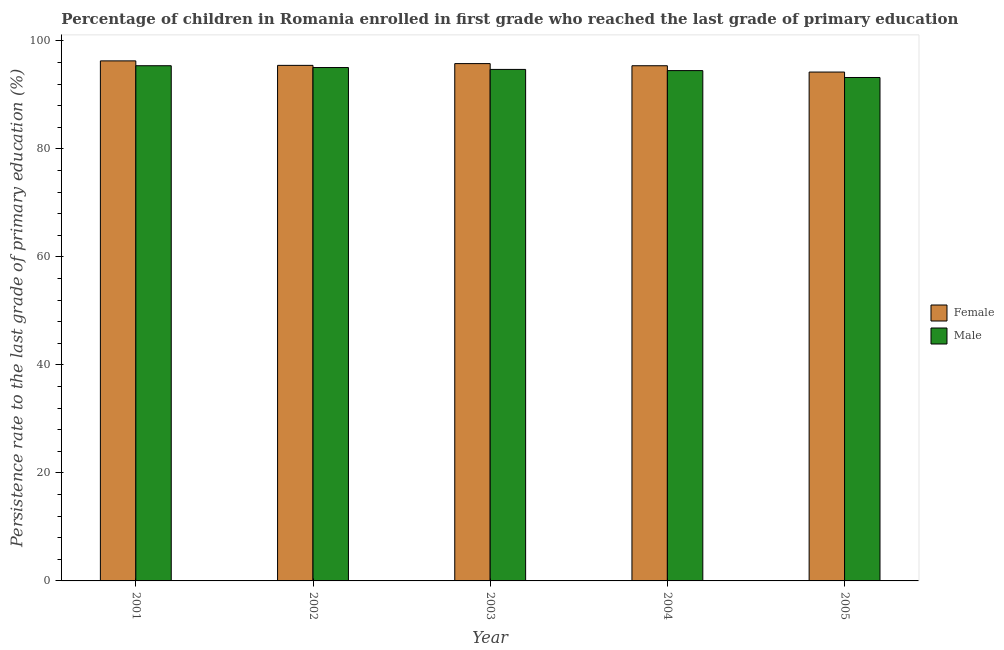How many groups of bars are there?
Provide a succinct answer. 5. Are the number of bars on each tick of the X-axis equal?
Ensure brevity in your answer.  Yes. How many bars are there on the 1st tick from the left?
Your response must be concise. 2. What is the persistence rate of female students in 2004?
Make the answer very short. 95.39. Across all years, what is the maximum persistence rate of male students?
Make the answer very short. 95.39. Across all years, what is the minimum persistence rate of male students?
Your response must be concise. 93.21. In which year was the persistence rate of female students maximum?
Ensure brevity in your answer.  2001. What is the total persistence rate of female students in the graph?
Your answer should be compact. 477.14. What is the difference between the persistence rate of female students in 2003 and that in 2005?
Offer a very short reply. 1.57. What is the difference between the persistence rate of male students in 2004 and the persistence rate of female students in 2002?
Provide a succinct answer. -0.57. What is the average persistence rate of female students per year?
Provide a short and direct response. 95.43. In the year 2003, what is the difference between the persistence rate of female students and persistence rate of male students?
Your answer should be very brief. 0. In how many years, is the persistence rate of male students greater than 68 %?
Make the answer very short. 5. What is the ratio of the persistence rate of female students in 2001 to that in 2003?
Ensure brevity in your answer.  1.01. Is the persistence rate of female students in 2002 less than that in 2004?
Keep it short and to the point. No. Is the difference between the persistence rate of male students in 2002 and 2004 greater than the difference between the persistence rate of female students in 2002 and 2004?
Offer a terse response. No. What is the difference between the highest and the second highest persistence rate of female students?
Make the answer very short. 0.5. What is the difference between the highest and the lowest persistence rate of female students?
Offer a terse response. 2.07. Is the sum of the persistence rate of female students in 2001 and 2003 greater than the maximum persistence rate of male students across all years?
Your answer should be compact. Yes. What does the 2nd bar from the right in 2002 represents?
Give a very brief answer. Female. How many bars are there?
Your answer should be very brief. 10. How many years are there in the graph?
Keep it short and to the point. 5. What is the difference between two consecutive major ticks on the Y-axis?
Your answer should be compact. 20. Where does the legend appear in the graph?
Provide a succinct answer. Center right. What is the title of the graph?
Provide a succinct answer. Percentage of children in Romania enrolled in first grade who reached the last grade of primary education. What is the label or title of the Y-axis?
Make the answer very short. Persistence rate to the last grade of primary education (%). What is the Persistence rate to the last grade of primary education (%) of Female in 2001?
Your answer should be compact. 96.29. What is the Persistence rate to the last grade of primary education (%) in Male in 2001?
Offer a very short reply. 95.39. What is the Persistence rate to the last grade of primary education (%) of Female in 2002?
Give a very brief answer. 95.46. What is the Persistence rate to the last grade of primary education (%) of Male in 2002?
Offer a very short reply. 95.05. What is the Persistence rate to the last grade of primary education (%) of Female in 2003?
Give a very brief answer. 95.78. What is the Persistence rate to the last grade of primary education (%) of Male in 2003?
Ensure brevity in your answer.  94.71. What is the Persistence rate to the last grade of primary education (%) in Female in 2004?
Keep it short and to the point. 95.39. What is the Persistence rate to the last grade of primary education (%) in Male in 2004?
Provide a short and direct response. 94.49. What is the Persistence rate to the last grade of primary education (%) in Female in 2005?
Ensure brevity in your answer.  94.22. What is the Persistence rate to the last grade of primary education (%) of Male in 2005?
Give a very brief answer. 93.21. Across all years, what is the maximum Persistence rate to the last grade of primary education (%) in Female?
Make the answer very short. 96.29. Across all years, what is the maximum Persistence rate to the last grade of primary education (%) of Male?
Offer a terse response. 95.39. Across all years, what is the minimum Persistence rate to the last grade of primary education (%) of Female?
Your answer should be very brief. 94.22. Across all years, what is the minimum Persistence rate to the last grade of primary education (%) in Male?
Provide a short and direct response. 93.21. What is the total Persistence rate to the last grade of primary education (%) in Female in the graph?
Your answer should be very brief. 477.14. What is the total Persistence rate to the last grade of primary education (%) of Male in the graph?
Offer a terse response. 472.86. What is the difference between the Persistence rate to the last grade of primary education (%) of Female in 2001 and that in 2002?
Provide a succinct answer. 0.83. What is the difference between the Persistence rate to the last grade of primary education (%) of Male in 2001 and that in 2002?
Ensure brevity in your answer.  0.34. What is the difference between the Persistence rate to the last grade of primary education (%) of Female in 2001 and that in 2003?
Your answer should be compact. 0.51. What is the difference between the Persistence rate to the last grade of primary education (%) in Male in 2001 and that in 2003?
Give a very brief answer. 0.68. What is the difference between the Persistence rate to the last grade of primary education (%) of Female in 2001 and that in 2004?
Ensure brevity in your answer.  0.9. What is the difference between the Persistence rate to the last grade of primary education (%) in Male in 2001 and that in 2004?
Provide a succinct answer. 0.9. What is the difference between the Persistence rate to the last grade of primary education (%) in Female in 2001 and that in 2005?
Make the answer very short. 2.07. What is the difference between the Persistence rate to the last grade of primary education (%) of Male in 2001 and that in 2005?
Provide a short and direct response. 2.18. What is the difference between the Persistence rate to the last grade of primary education (%) of Female in 2002 and that in 2003?
Provide a short and direct response. -0.33. What is the difference between the Persistence rate to the last grade of primary education (%) of Male in 2002 and that in 2003?
Make the answer very short. 0.35. What is the difference between the Persistence rate to the last grade of primary education (%) of Female in 2002 and that in 2004?
Keep it short and to the point. 0.07. What is the difference between the Persistence rate to the last grade of primary education (%) of Male in 2002 and that in 2004?
Provide a short and direct response. 0.56. What is the difference between the Persistence rate to the last grade of primary education (%) in Female in 2002 and that in 2005?
Ensure brevity in your answer.  1.24. What is the difference between the Persistence rate to the last grade of primary education (%) in Male in 2002 and that in 2005?
Ensure brevity in your answer.  1.84. What is the difference between the Persistence rate to the last grade of primary education (%) in Female in 2003 and that in 2004?
Make the answer very short. 0.4. What is the difference between the Persistence rate to the last grade of primary education (%) in Male in 2003 and that in 2004?
Provide a succinct answer. 0.22. What is the difference between the Persistence rate to the last grade of primary education (%) in Female in 2003 and that in 2005?
Provide a succinct answer. 1.57. What is the difference between the Persistence rate to the last grade of primary education (%) of Male in 2003 and that in 2005?
Your answer should be very brief. 1.5. What is the difference between the Persistence rate to the last grade of primary education (%) of Female in 2004 and that in 2005?
Ensure brevity in your answer.  1.17. What is the difference between the Persistence rate to the last grade of primary education (%) in Male in 2004 and that in 2005?
Offer a terse response. 1.28. What is the difference between the Persistence rate to the last grade of primary education (%) of Female in 2001 and the Persistence rate to the last grade of primary education (%) of Male in 2002?
Your response must be concise. 1.23. What is the difference between the Persistence rate to the last grade of primary education (%) in Female in 2001 and the Persistence rate to the last grade of primary education (%) in Male in 2003?
Give a very brief answer. 1.58. What is the difference between the Persistence rate to the last grade of primary education (%) in Female in 2001 and the Persistence rate to the last grade of primary education (%) in Male in 2004?
Your answer should be compact. 1.8. What is the difference between the Persistence rate to the last grade of primary education (%) in Female in 2001 and the Persistence rate to the last grade of primary education (%) in Male in 2005?
Offer a terse response. 3.08. What is the difference between the Persistence rate to the last grade of primary education (%) of Female in 2002 and the Persistence rate to the last grade of primary education (%) of Male in 2003?
Keep it short and to the point. 0.75. What is the difference between the Persistence rate to the last grade of primary education (%) of Female in 2002 and the Persistence rate to the last grade of primary education (%) of Male in 2004?
Your answer should be very brief. 0.97. What is the difference between the Persistence rate to the last grade of primary education (%) in Female in 2002 and the Persistence rate to the last grade of primary education (%) in Male in 2005?
Provide a succinct answer. 2.25. What is the difference between the Persistence rate to the last grade of primary education (%) in Female in 2003 and the Persistence rate to the last grade of primary education (%) in Male in 2004?
Offer a very short reply. 1.29. What is the difference between the Persistence rate to the last grade of primary education (%) in Female in 2003 and the Persistence rate to the last grade of primary education (%) in Male in 2005?
Offer a terse response. 2.57. What is the difference between the Persistence rate to the last grade of primary education (%) of Female in 2004 and the Persistence rate to the last grade of primary education (%) of Male in 2005?
Ensure brevity in your answer.  2.18. What is the average Persistence rate to the last grade of primary education (%) of Female per year?
Provide a short and direct response. 95.43. What is the average Persistence rate to the last grade of primary education (%) of Male per year?
Offer a very short reply. 94.57. In the year 2001, what is the difference between the Persistence rate to the last grade of primary education (%) of Female and Persistence rate to the last grade of primary education (%) of Male?
Give a very brief answer. 0.9. In the year 2002, what is the difference between the Persistence rate to the last grade of primary education (%) in Female and Persistence rate to the last grade of primary education (%) in Male?
Give a very brief answer. 0.4. In the year 2003, what is the difference between the Persistence rate to the last grade of primary education (%) of Female and Persistence rate to the last grade of primary education (%) of Male?
Your answer should be very brief. 1.07. In the year 2004, what is the difference between the Persistence rate to the last grade of primary education (%) in Female and Persistence rate to the last grade of primary education (%) in Male?
Give a very brief answer. 0.9. What is the ratio of the Persistence rate to the last grade of primary education (%) in Female in 2001 to that in 2002?
Your answer should be very brief. 1.01. What is the ratio of the Persistence rate to the last grade of primary education (%) in Female in 2001 to that in 2003?
Provide a succinct answer. 1.01. What is the ratio of the Persistence rate to the last grade of primary education (%) of Male in 2001 to that in 2003?
Make the answer very short. 1.01. What is the ratio of the Persistence rate to the last grade of primary education (%) in Female in 2001 to that in 2004?
Your answer should be very brief. 1.01. What is the ratio of the Persistence rate to the last grade of primary education (%) of Male in 2001 to that in 2004?
Keep it short and to the point. 1.01. What is the ratio of the Persistence rate to the last grade of primary education (%) of Male in 2001 to that in 2005?
Give a very brief answer. 1.02. What is the ratio of the Persistence rate to the last grade of primary education (%) of Female in 2002 to that in 2004?
Your response must be concise. 1. What is the ratio of the Persistence rate to the last grade of primary education (%) in Male in 2002 to that in 2004?
Provide a short and direct response. 1.01. What is the ratio of the Persistence rate to the last grade of primary education (%) in Female in 2002 to that in 2005?
Make the answer very short. 1.01. What is the ratio of the Persistence rate to the last grade of primary education (%) of Male in 2002 to that in 2005?
Offer a terse response. 1.02. What is the ratio of the Persistence rate to the last grade of primary education (%) in Female in 2003 to that in 2004?
Provide a short and direct response. 1. What is the ratio of the Persistence rate to the last grade of primary education (%) of Female in 2003 to that in 2005?
Your answer should be compact. 1.02. What is the ratio of the Persistence rate to the last grade of primary education (%) of Male in 2003 to that in 2005?
Give a very brief answer. 1.02. What is the ratio of the Persistence rate to the last grade of primary education (%) in Female in 2004 to that in 2005?
Provide a short and direct response. 1.01. What is the ratio of the Persistence rate to the last grade of primary education (%) in Male in 2004 to that in 2005?
Provide a short and direct response. 1.01. What is the difference between the highest and the second highest Persistence rate to the last grade of primary education (%) of Female?
Give a very brief answer. 0.51. What is the difference between the highest and the second highest Persistence rate to the last grade of primary education (%) of Male?
Offer a terse response. 0.34. What is the difference between the highest and the lowest Persistence rate to the last grade of primary education (%) in Female?
Make the answer very short. 2.07. What is the difference between the highest and the lowest Persistence rate to the last grade of primary education (%) of Male?
Your answer should be compact. 2.18. 